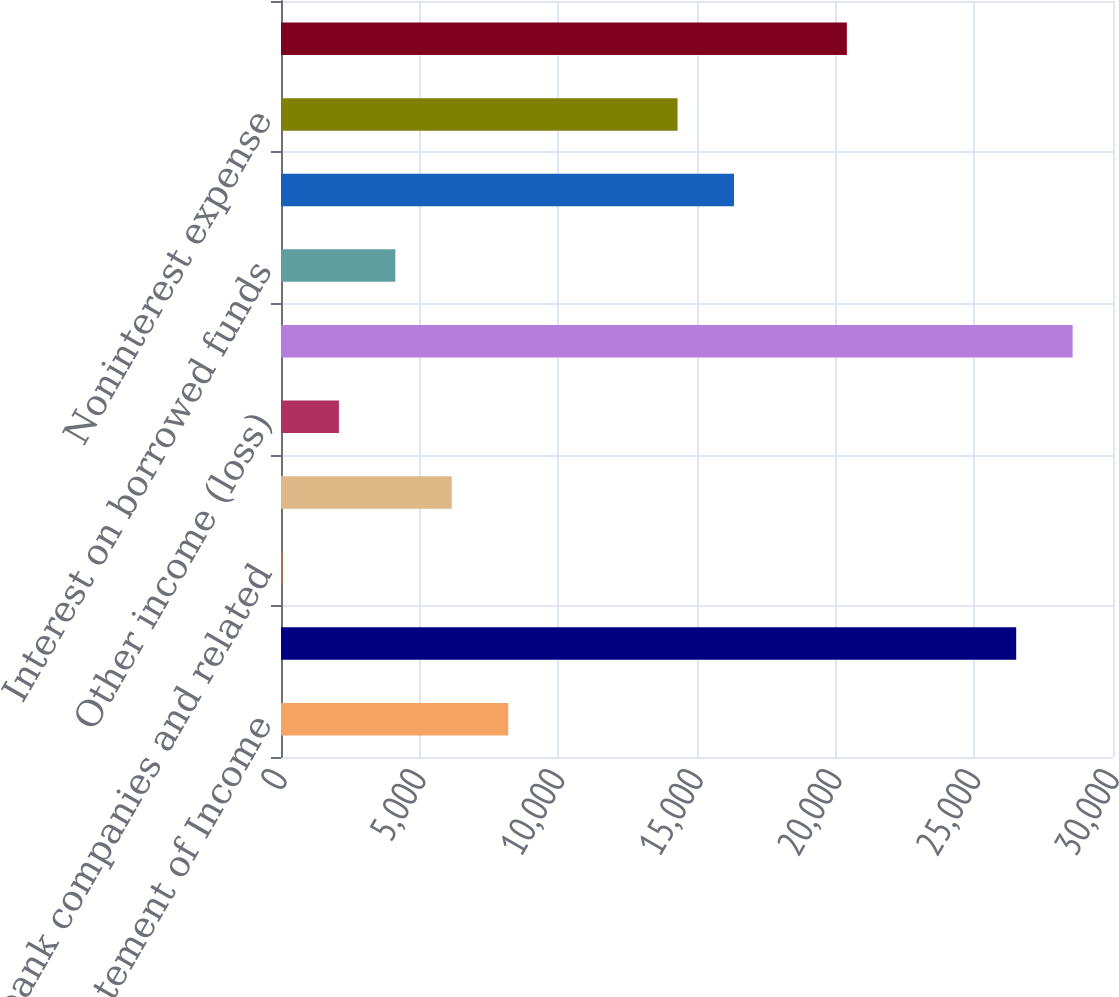<chart> <loc_0><loc_0><loc_500><loc_500><bar_chart><fcel>Condensed Statement of Income<fcel>Bank holding companies and<fcel>Nonbank companies and related<fcel>Interest from subsidiaries<fcel>Other income (loss)<fcel>Total income<fcel>Interest on borrowed funds<fcel>Other interest expense<fcel>Noninterest expense<fcel>Total expense<nl><fcel>8193.4<fcel>26509.3<fcel>53<fcel>6158.3<fcel>2088.1<fcel>28544.4<fcel>4123.2<fcel>16333.8<fcel>14298.7<fcel>20404<nl></chart> 